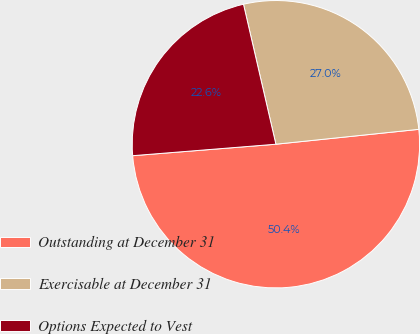Convert chart. <chart><loc_0><loc_0><loc_500><loc_500><pie_chart><fcel>Outstanding at December 31<fcel>Exercisable at December 31<fcel>Options Expected to Vest<nl><fcel>50.38%<fcel>26.97%<fcel>22.65%<nl></chart> 